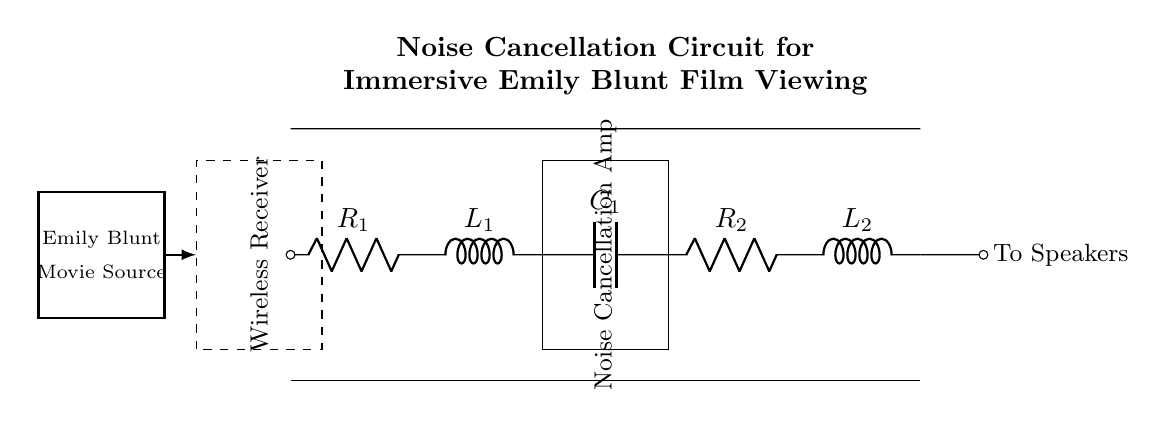What is the role of the inductor in this circuit? The inductor in this circuit, specifically L1 and L2, helps filter out unwanted noise by allowing low-frequency signals to pass while impeding high-frequency signals, thereby contributing to the noise cancellation process.
Answer: filter noise What components are used in this noise cancellation circuit? The circuit consists of resistors, inductors, and a capacitor, specifically R1, R2, L1, L2, and C1, which work together to execute the noise cancellation function.
Answer: resistors, inductors, capacitor What is the output of this circuit connected to? The output of the circuit is connected to the speakers, as indicated by the label "To Speakers" at the end of the circuit pathway.
Answer: speakers What type of circuit is this? This circuit is an RLC circuit, comprised of resistors, inductors, and capacitors, which are strategically arranged for noise cancellation in wireless headphones.
Answer: RLC circuit Why is amplification included in this circuit? Amplification is included to enhance the audio signal after noise cancellation, ensuring that the sound reaches a suitable level for immersive viewing of films, thereby improving the overall listening experience.
Answer: enhance audio signal What purpose does the wireless receiver serve in this circuit? The wireless receiver receives audio signals from the Emily Blunt movie source, translating them into an electrical form that can be processed by the remainder of the circuit for noise cancellation.
Answer: receive audio signals What does the label "Emily Blunt Movie Source" indicate? The label indicates the origin of the audio signal, which is specifically sourced from an Emily Blunt film, and signifies that the circuit is designed for immersive movie viewing.
Answer: movie source 